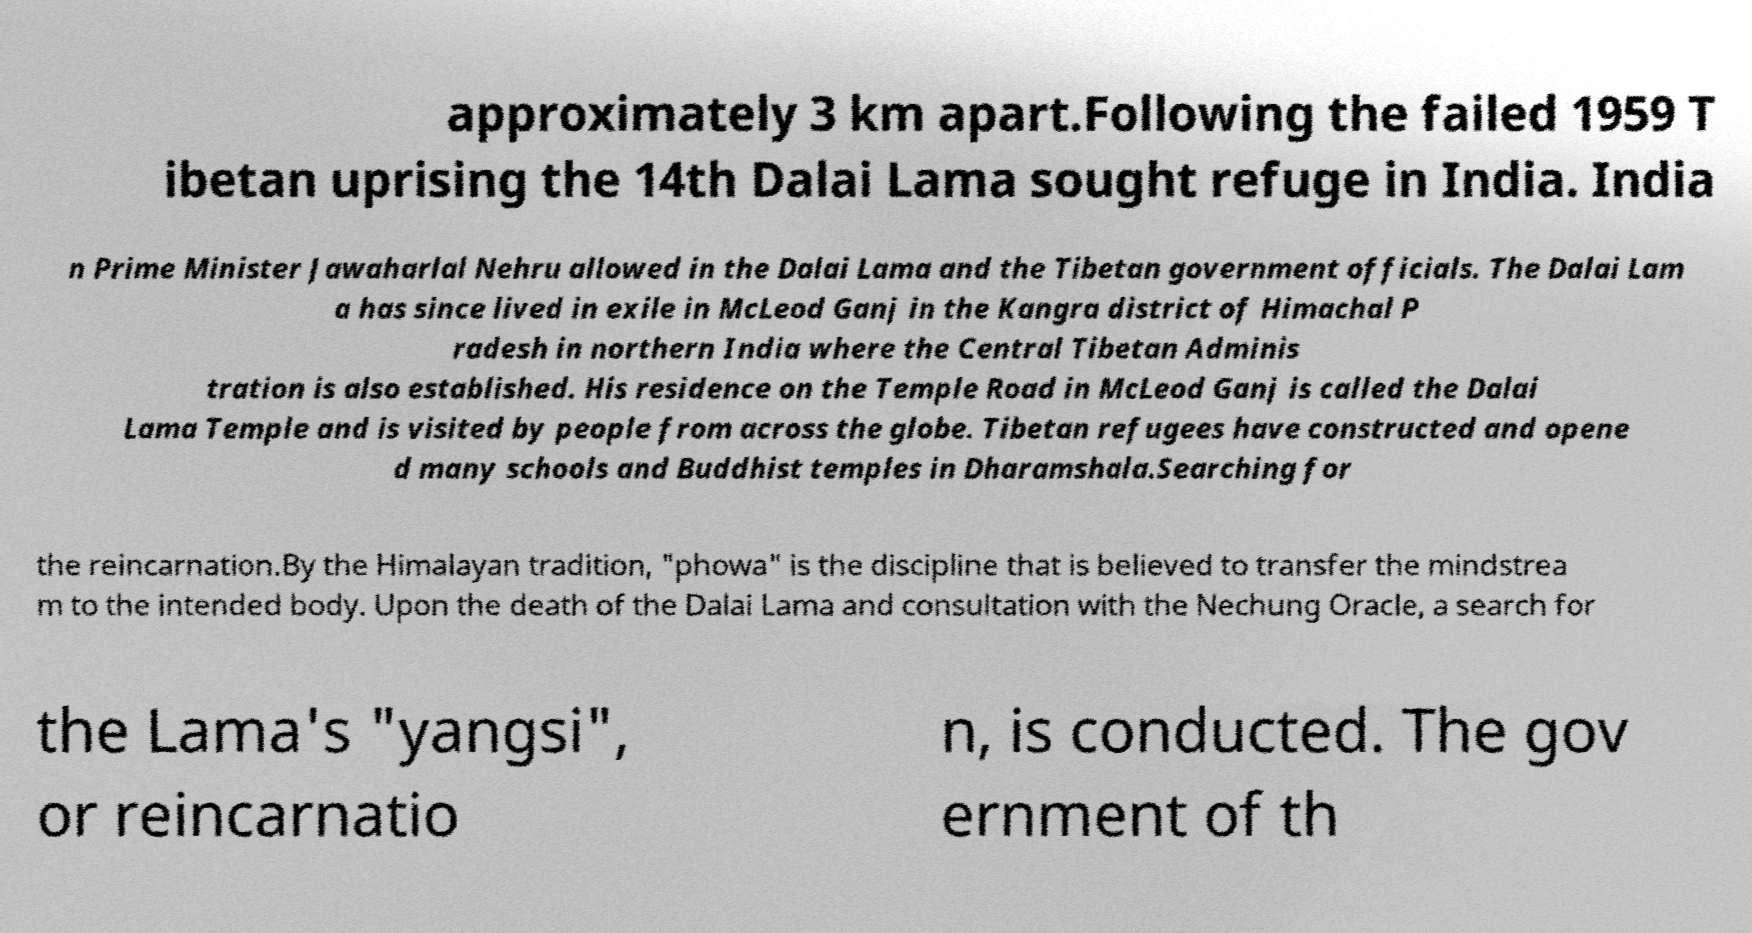For documentation purposes, I need the text within this image transcribed. Could you provide that? approximately 3 km apart.Following the failed 1959 T ibetan uprising the 14th Dalai Lama sought refuge in India. India n Prime Minister Jawaharlal Nehru allowed in the Dalai Lama and the Tibetan government officials. The Dalai Lam a has since lived in exile in McLeod Ganj in the Kangra district of Himachal P radesh in northern India where the Central Tibetan Adminis tration is also established. His residence on the Temple Road in McLeod Ganj is called the Dalai Lama Temple and is visited by people from across the globe. Tibetan refugees have constructed and opene d many schools and Buddhist temples in Dharamshala.Searching for the reincarnation.By the Himalayan tradition, "phowa" is the discipline that is believed to transfer the mindstrea m to the intended body. Upon the death of the Dalai Lama and consultation with the Nechung Oracle, a search for the Lama's "yangsi", or reincarnatio n, is conducted. The gov ernment of th 